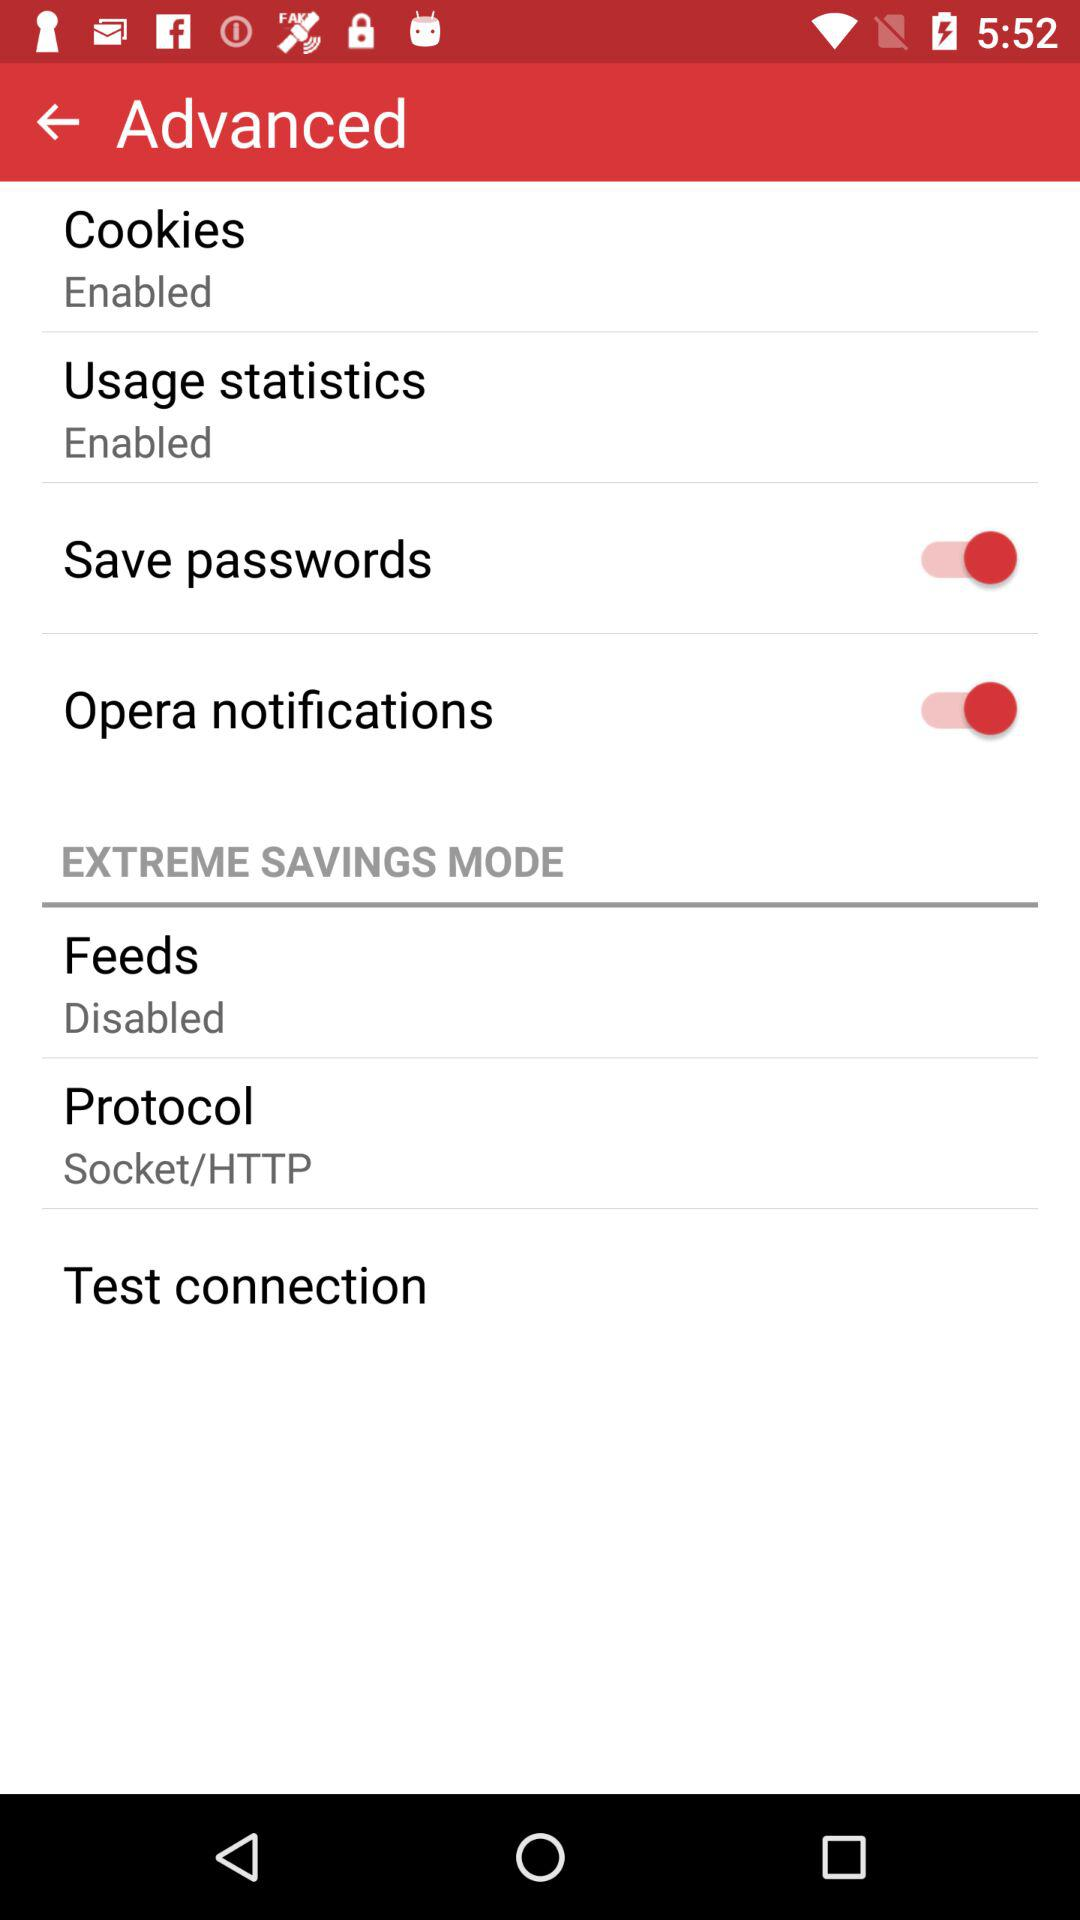What is the current status of "Opera notifications"? The status is "on". 